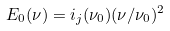<formula> <loc_0><loc_0><loc_500><loc_500>E _ { 0 } ( \nu ) = i _ { j } ( \nu _ { 0 } ) ( \nu / \nu _ { 0 } ) ^ { 2 }</formula> 